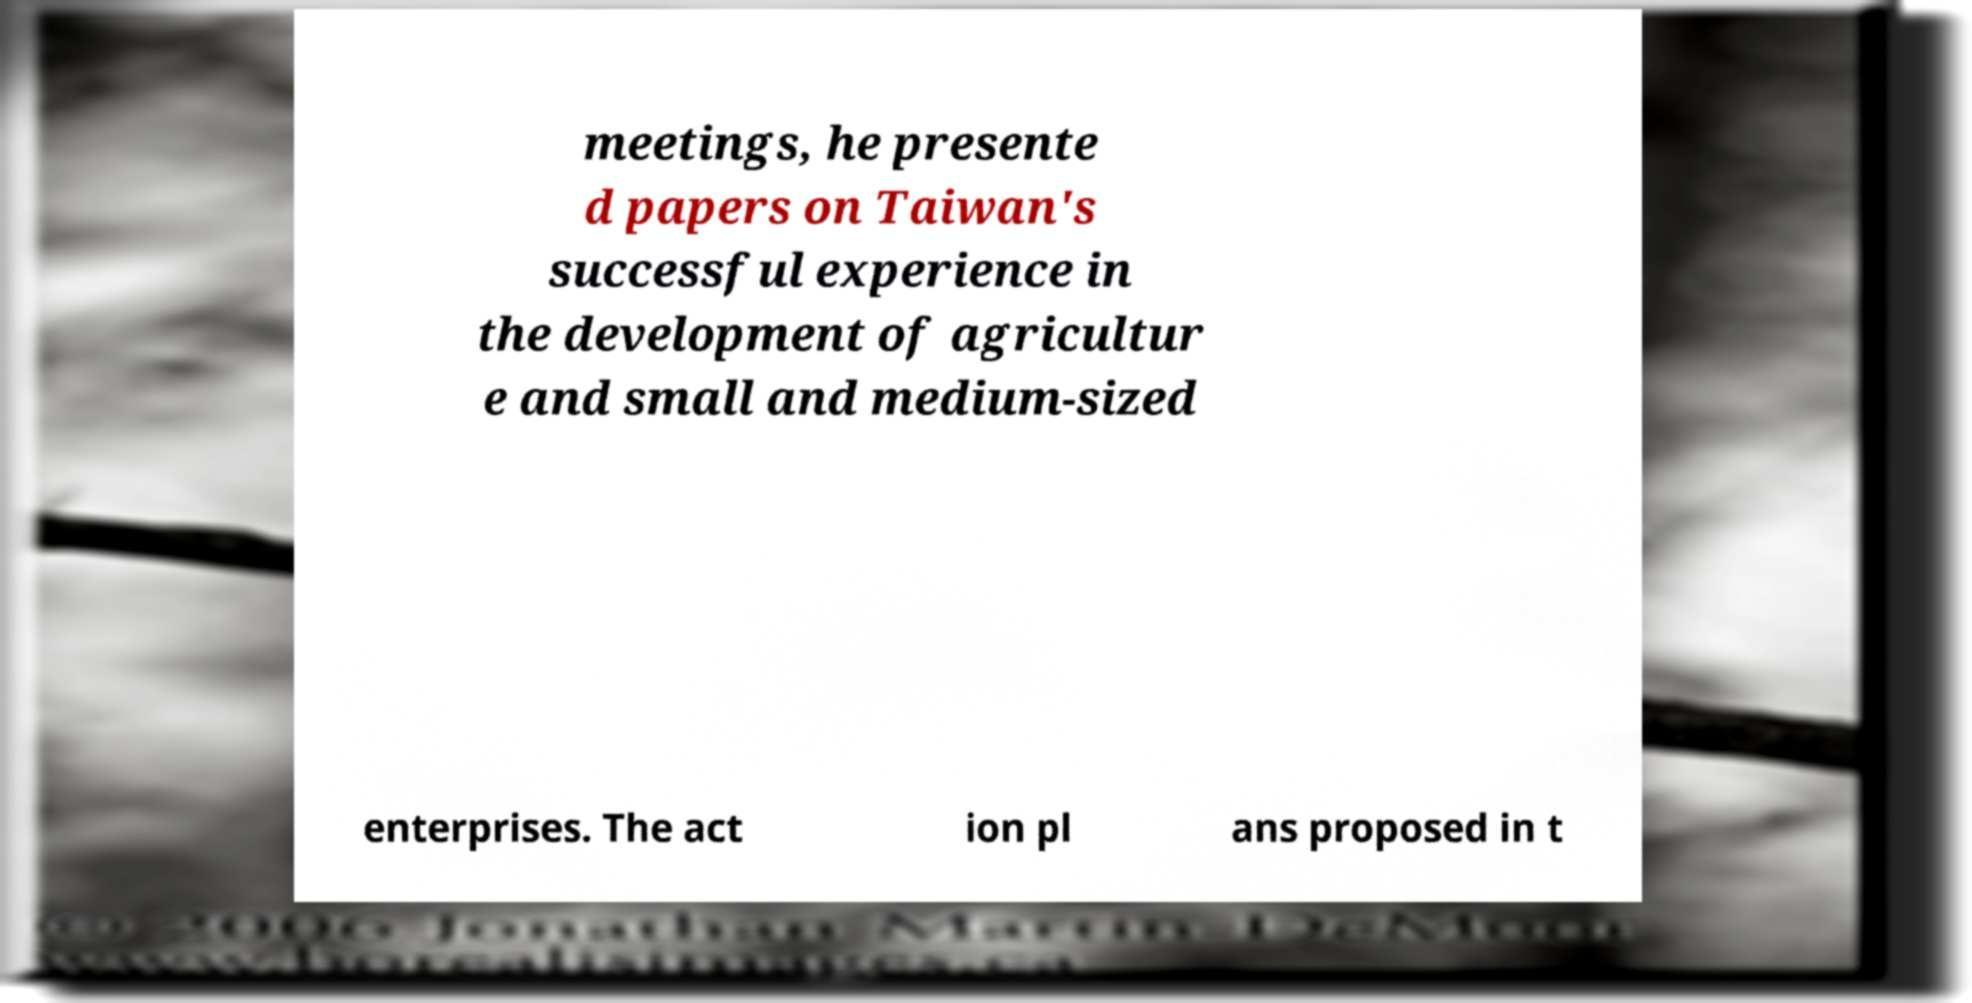Can you accurately transcribe the text from the provided image for me? meetings, he presente d papers on Taiwan's successful experience in the development of agricultur e and small and medium-sized enterprises. The act ion pl ans proposed in t 